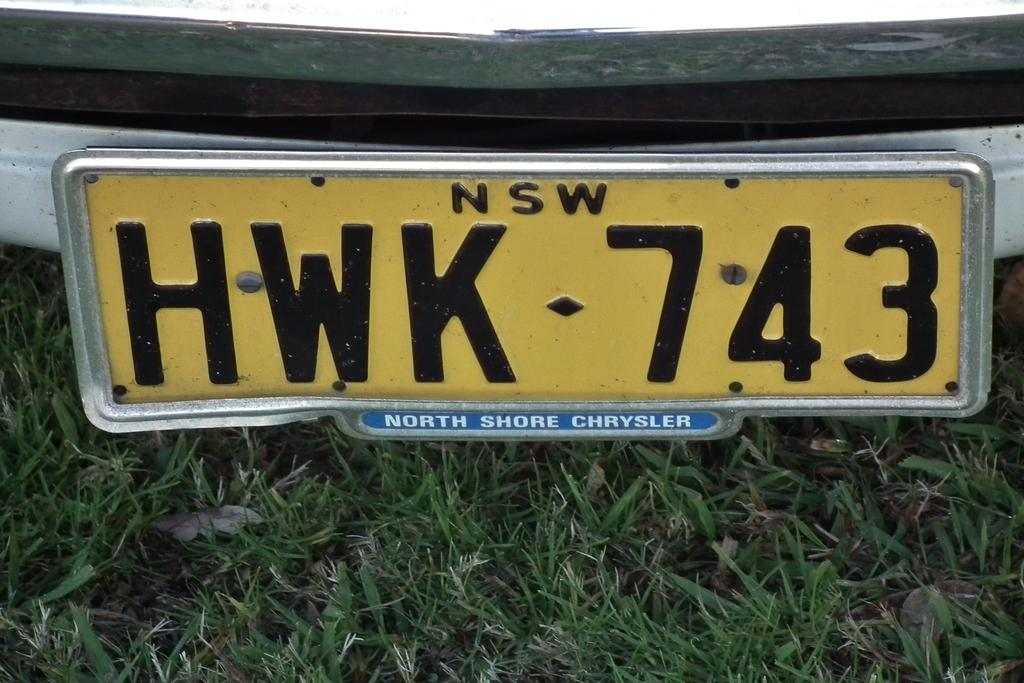<image>
Present a compact description of the photo's key features. Yellow license plate which says HWK 743 on it. 